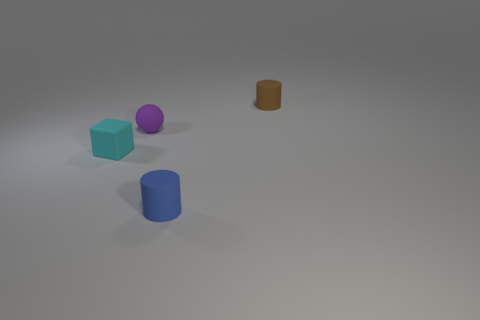Add 2 blue things. How many objects exist? 6 Subtract all balls. How many objects are left? 3 Add 3 tiny purple matte things. How many tiny purple matte things are left? 4 Add 4 purple matte spheres. How many purple matte spheres exist? 5 Subtract 1 cyan cubes. How many objects are left? 3 Subtract all big brown rubber cubes. Subtract all blue rubber things. How many objects are left? 3 